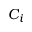<formula> <loc_0><loc_0><loc_500><loc_500>C _ { i }</formula> 